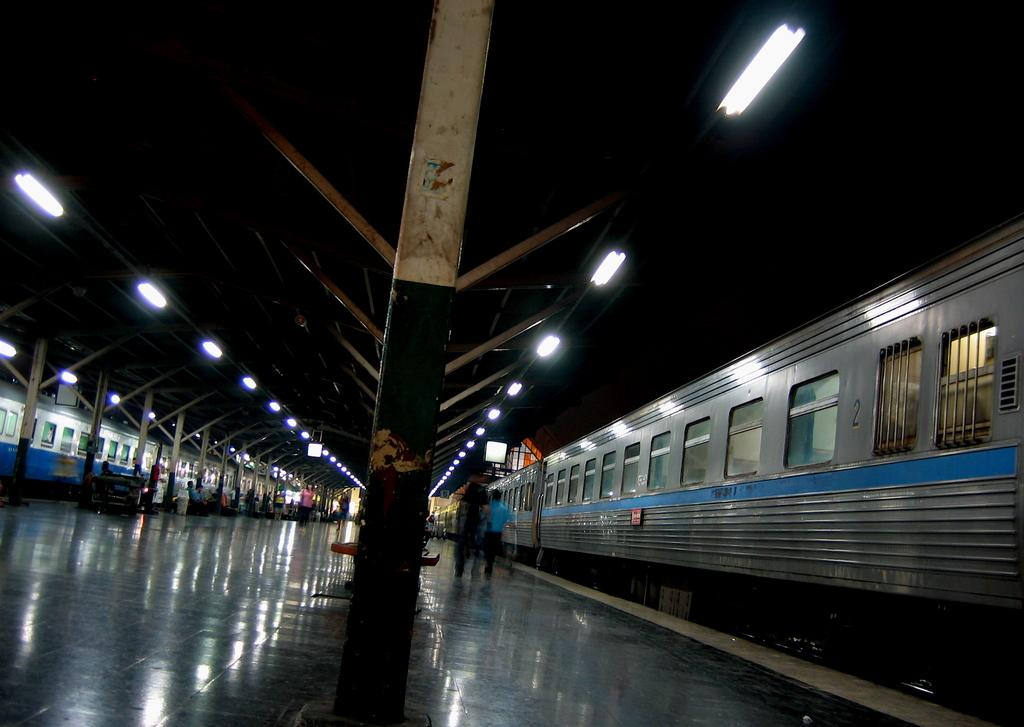What type of location is depicted in the image? The image was likely taken at a railway station. How many trains can be seen in the image? There are two trains in the image. What type of lighting is present in the image? There are tube lights visible in the image. What are the people in the image doing? There are people sitting and standing in the image. What is the main feature of the location shown in the image? The image shows a platform. What type of army equipment can be seen in the image? There is no army equipment present in the image; it shows a railway station with trains and people. How does the heat affect the people in the image? The image does not provide any information about the temperature or heat, so it cannot be determined how it affects the people in the image. 